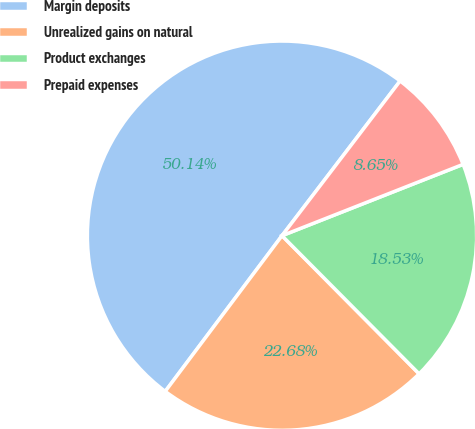Convert chart. <chart><loc_0><loc_0><loc_500><loc_500><pie_chart><fcel>Margin deposits<fcel>Unrealized gains on natural<fcel>Product exchanges<fcel>Prepaid expenses<nl><fcel>50.13%<fcel>22.68%<fcel>18.53%<fcel>8.65%<nl></chart> 